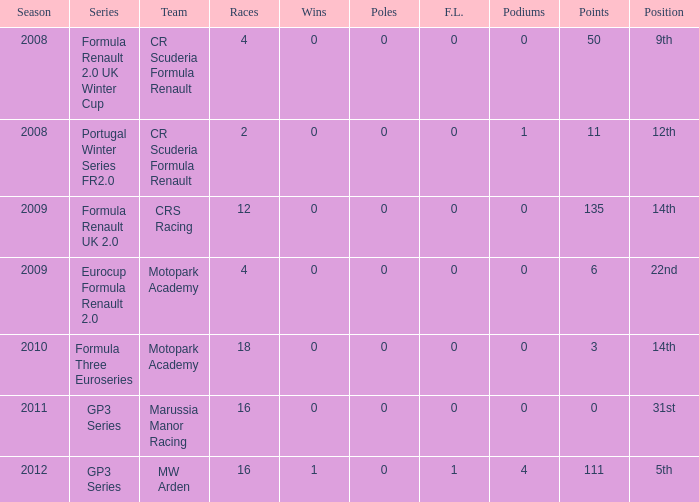How many f.l. are documented for formula three euroseries? 1.0. 